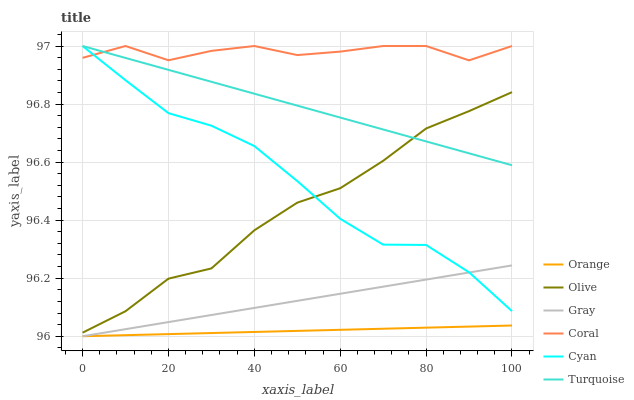Does Orange have the minimum area under the curve?
Answer yes or no. Yes. Does Coral have the maximum area under the curve?
Answer yes or no. Yes. Does Turquoise have the minimum area under the curve?
Answer yes or no. No. Does Turquoise have the maximum area under the curve?
Answer yes or no. No. Is Gray the smoothest?
Answer yes or no. Yes. Is Coral the roughest?
Answer yes or no. Yes. Is Turquoise the smoothest?
Answer yes or no. No. Is Turquoise the roughest?
Answer yes or no. No. Does Gray have the lowest value?
Answer yes or no. Yes. Does Turquoise have the lowest value?
Answer yes or no. No. Does Cyan have the highest value?
Answer yes or no. Yes. Does Olive have the highest value?
Answer yes or no. No. Is Olive less than Coral?
Answer yes or no. Yes. Is Olive greater than Gray?
Answer yes or no. Yes. Does Cyan intersect Gray?
Answer yes or no. Yes. Is Cyan less than Gray?
Answer yes or no. No. Is Cyan greater than Gray?
Answer yes or no. No. Does Olive intersect Coral?
Answer yes or no. No. 